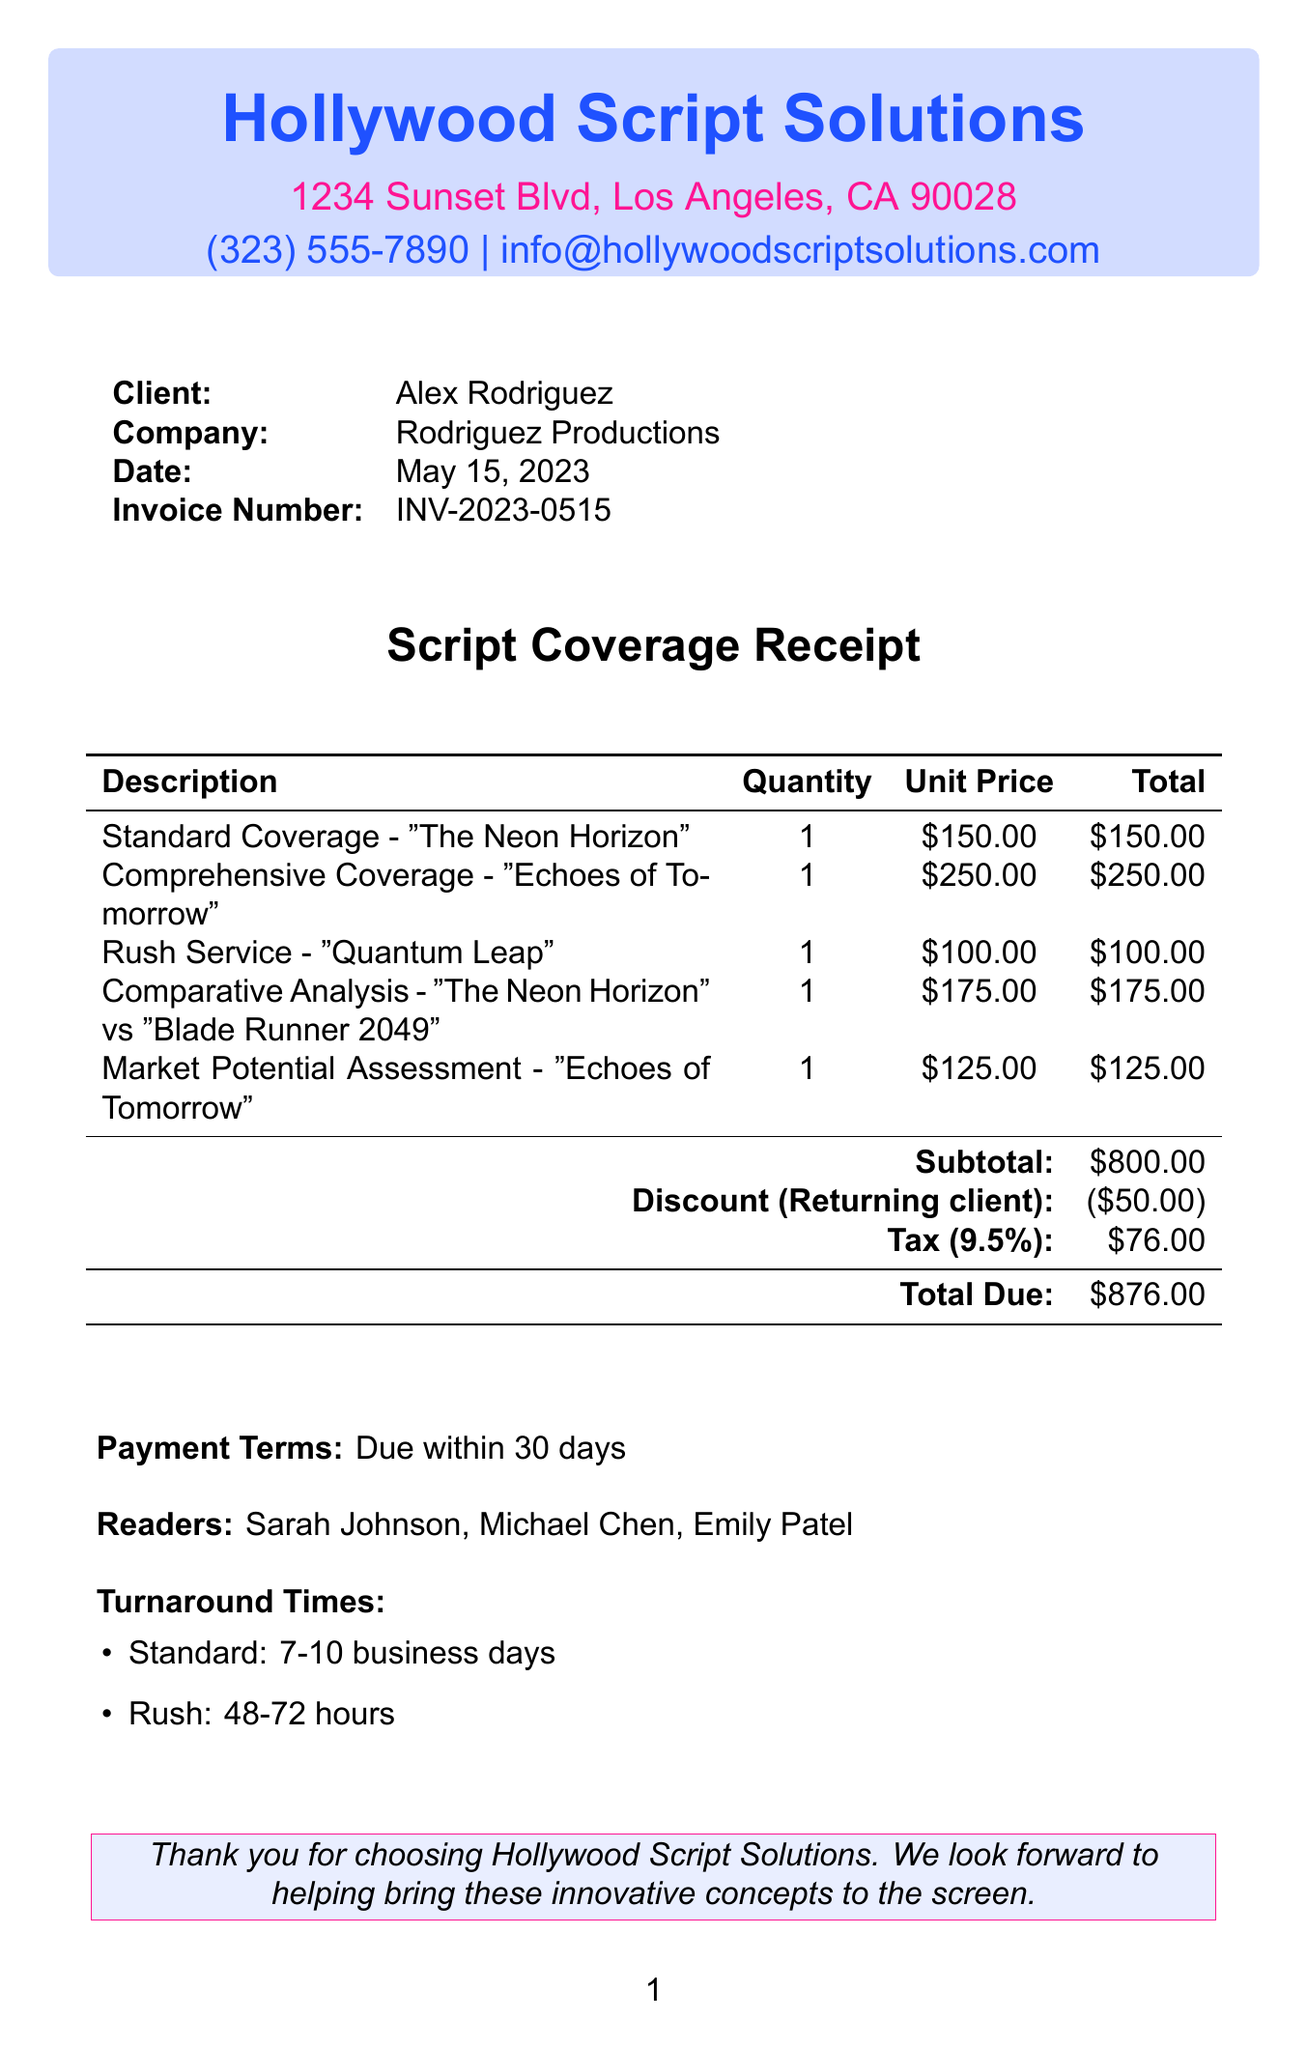What is the company name? The company name is listed at the top of the document.
Answer: Hollywood Script Solutions What is the subtotal amount? The subtotal is clearly indicated in the financial section of the document.
Answer: $800.00 Who is the client? The client's name is provided in the client section of the document.
Answer: Alex Rodriguez What service had the highest fee? By comparing the unit prices, the highest fee service is identified.
Answer: Comprehensive Coverage - 'Echoes of Tomorrow' What is the invoice number? The invoice number is explicitly stated in the document for reference.
Answer: INV-2023-0515 What is the tax rate applied? The tax rate is specified in the financial section of the document.
Answer: 9.5% What is the total due amount? The total due is calculated and presented at the end of the financial summary.
Answer: $876.00 What type of discount was applied? The document notes the type of discount given to the client.
Answer: Returning client discount What are the turnaround times for rush service? The turnaround time for rush service is outlined with specific hours.
Answer: 48-72 hours Who are the readers listed in the document? The readers' names are mentioned under their respective section.
Answer: Sarah Johnson, Michael Chen, Emily Patel 